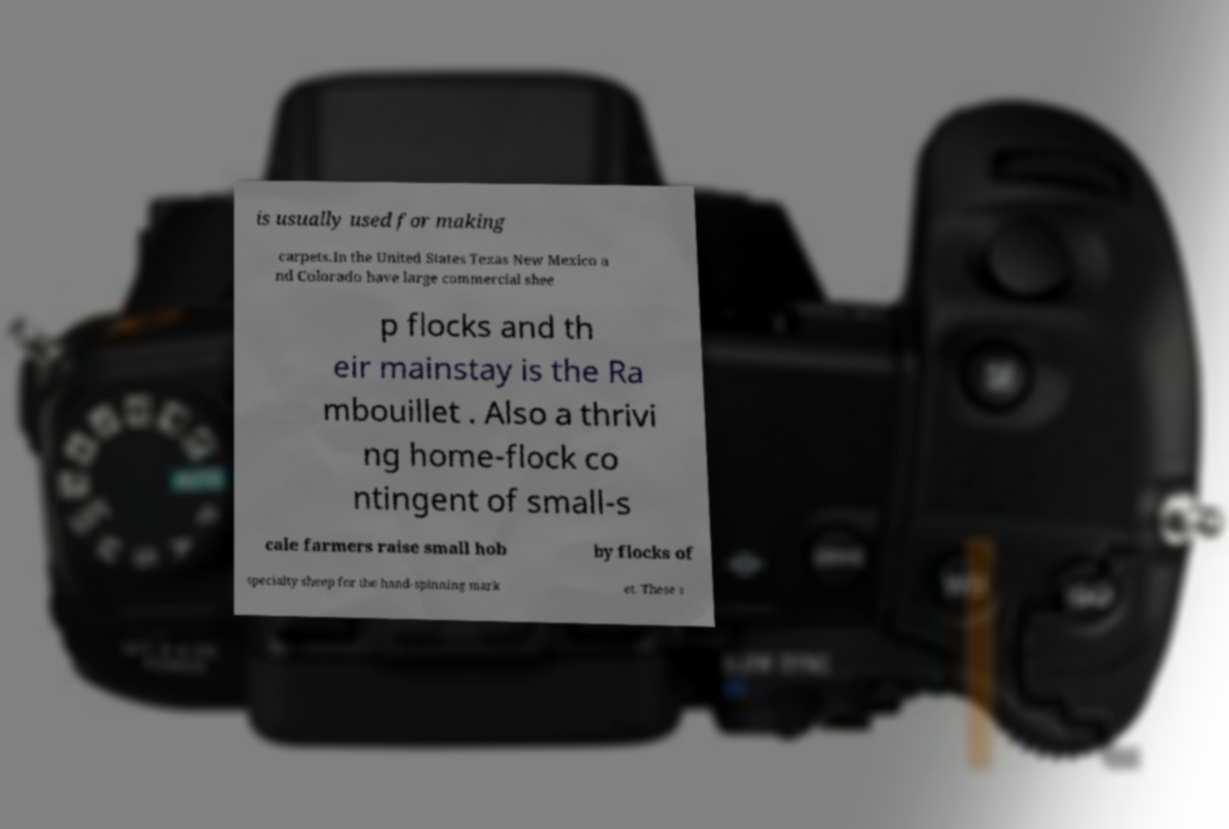Can you accurately transcribe the text from the provided image for me? is usually used for making carpets.In the United States Texas New Mexico a nd Colorado have large commercial shee p flocks and th eir mainstay is the Ra mbouillet . Also a thrivi ng home-flock co ntingent of small-s cale farmers raise small hob by flocks of specialty sheep for the hand-spinning mark et. These s 